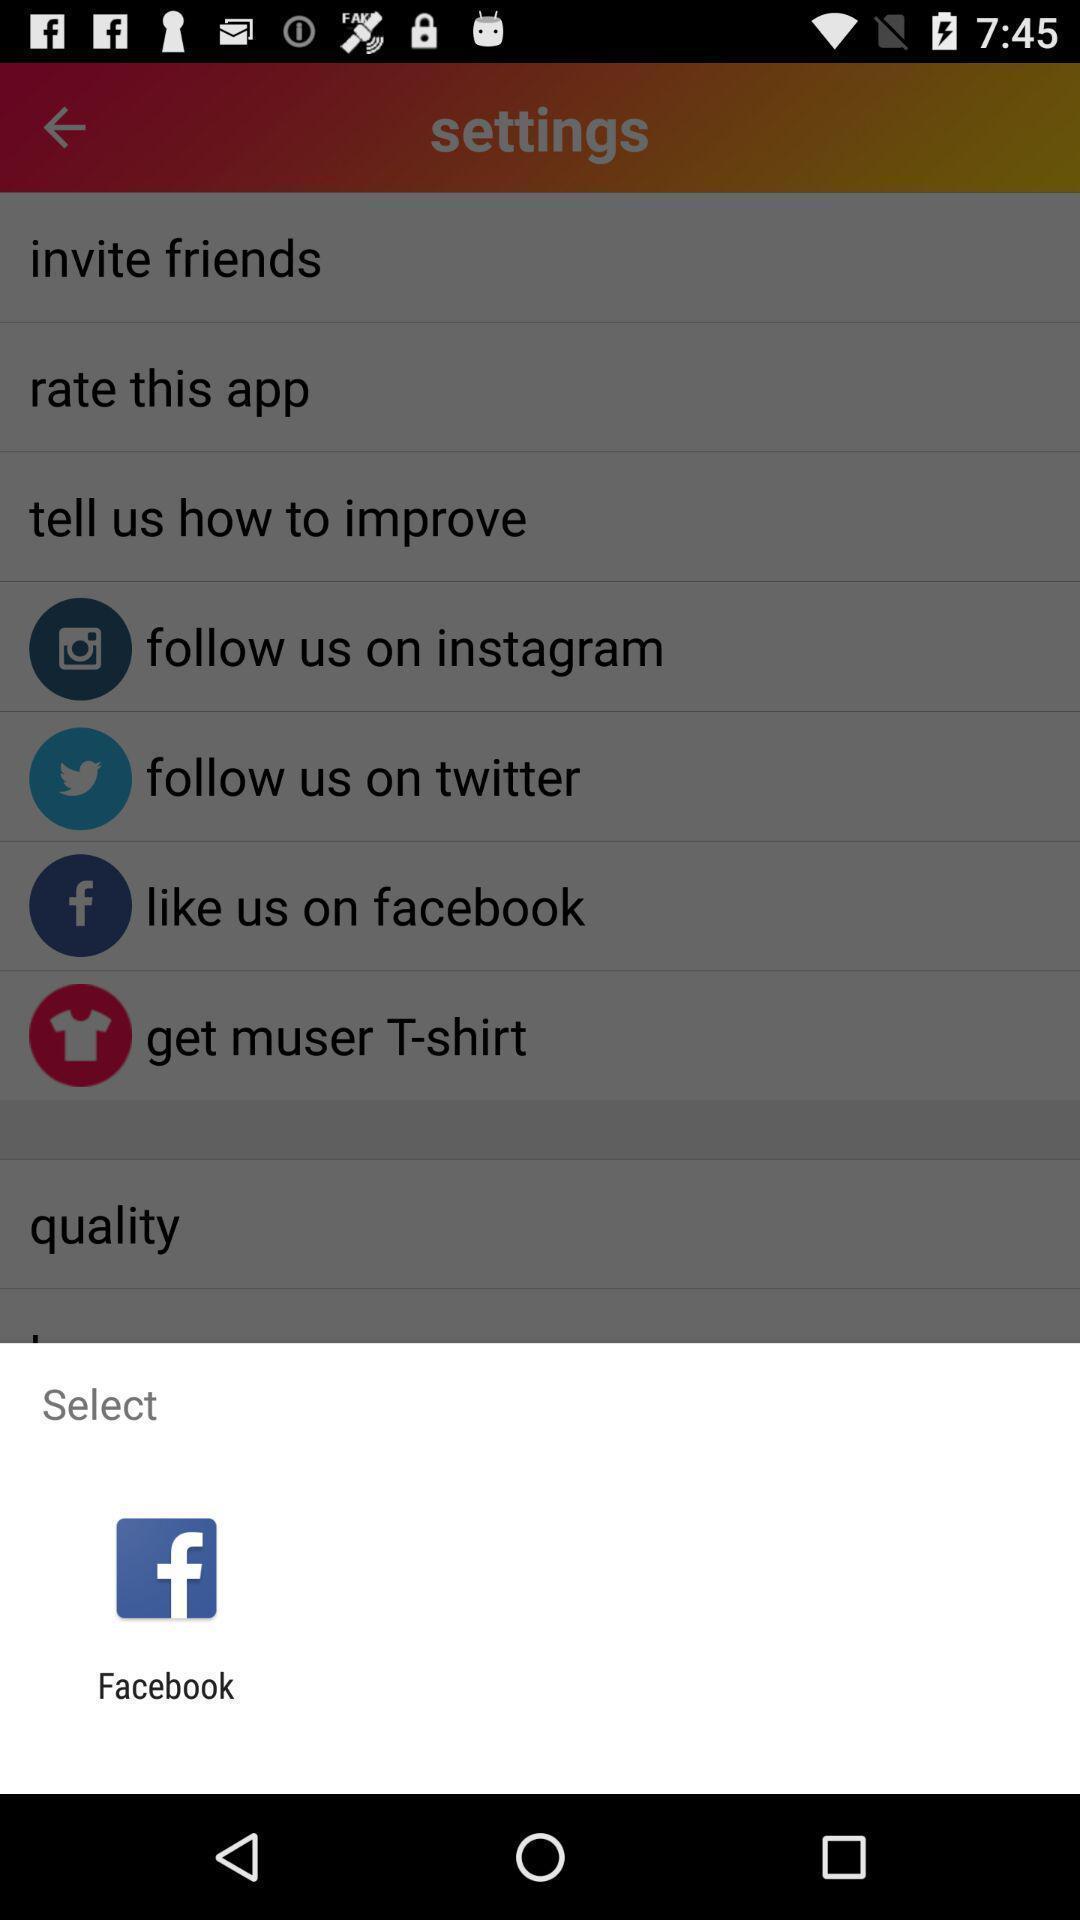Provide a textual representation of this image. Screen displaying to select the social application. 